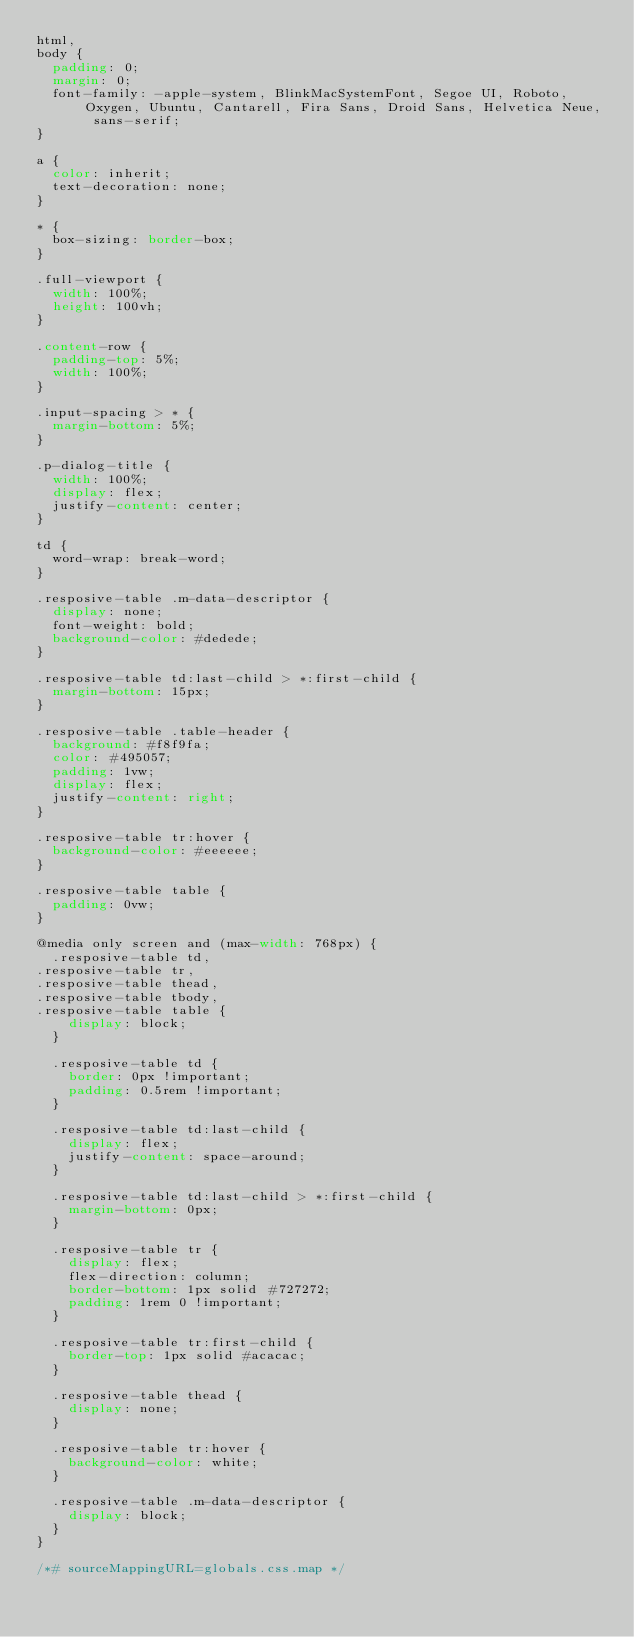Convert code to text. <code><loc_0><loc_0><loc_500><loc_500><_CSS_>html,
body {
  padding: 0;
  margin: 0;
  font-family: -apple-system, BlinkMacSystemFont, Segoe UI, Roboto, Oxygen, Ubuntu, Cantarell, Fira Sans, Droid Sans, Helvetica Neue, sans-serif;
}

a {
  color: inherit;
  text-decoration: none;
}

* {
  box-sizing: border-box;
}

.full-viewport {
  width: 100%;
  height: 100vh;
}

.content-row {
  padding-top: 5%;
  width: 100%;
}

.input-spacing > * {
  margin-bottom: 5%;
}

.p-dialog-title {
  width: 100%;
  display: flex;
  justify-content: center;
}

td {
  word-wrap: break-word;
}

.resposive-table .m-data-descriptor {
  display: none;
  font-weight: bold;
  background-color: #dedede;
}

.resposive-table td:last-child > *:first-child {
  margin-bottom: 15px;
}

.resposive-table .table-header {
  background: #f8f9fa;
  color: #495057;
  padding: 1vw;
  display: flex;
  justify-content: right;
}

.resposive-table tr:hover {
  background-color: #eeeeee;
}

.resposive-table table {
  padding: 0vw;
}

@media only screen and (max-width: 768px) {
  .resposive-table td,
.resposive-table tr,
.resposive-table thead,
.resposive-table tbody,
.resposive-table table {
    display: block;
  }

  .resposive-table td {
    border: 0px !important;
    padding: 0.5rem !important;
  }

  .resposive-table td:last-child {
    display: flex;
    justify-content: space-around;
  }

  .resposive-table td:last-child > *:first-child {
    margin-bottom: 0px;
  }

  .resposive-table tr {
    display: flex;
    flex-direction: column;
    border-bottom: 1px solid #727272;
    padding: 1rem 0 !important;
  }

  .resposive-table tr:first-child {
    border-top: 1px solid #acacac;
  }

  .resposive-table thead {
    display: none;
  }

  .resposive-table tr:hover {
    background-color: white;
  }

  .resposive-table .m-data-descriptor {
    display: block;
  }
}

/*# sourceMappingURL=globals.css.map */
</code> 